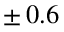Convert formula to latex. <formula><loc_0><loc_0><loc_500><loc_500>\pm \, 0 . 6 \, \</formula> 